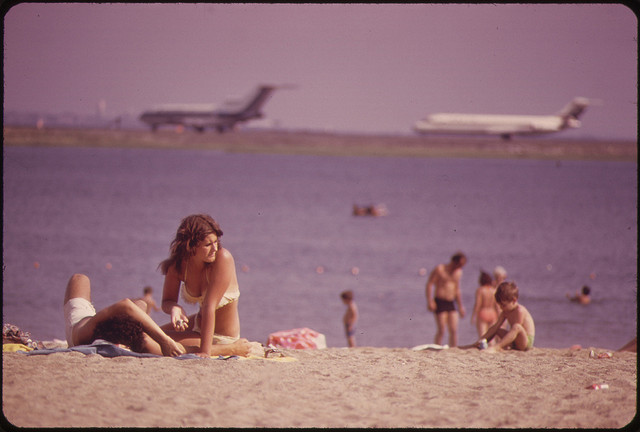Can you describe the setting of this image? Of course, the image captures a beach scene with an interesting juxtaposition. The foreground shows beachgoers indulging in typical seaside activities such as sunbathing and swimming. The background reveals an active airport with planes taking off or landing. This contrast creates a unique dynamic between the peacefulness of a beach day and the bustling energy of air travel. 